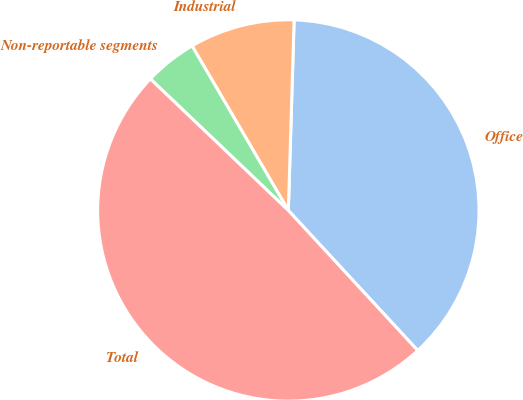Convert chart to OTSL. <chart><loc_0><loc_0><loc_500><loc_500><pie_chart><fcel>Office<fcel>Industrial<fcel>Non-reportable segments<fcel>Total<nl><fcel>37.65%<fcel>8.91%<fcel>4.45%<fcel>48.99%<nl></chart> 